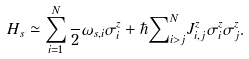<formula> <loc_0><loc_0><loc_500><loc_500>H _ { s } \simeq \sum _ { i = 1 } ^ { N } \frac { } { 2 } \omega _ { s , i } \sigma ^ { z } _ { i } + \hbar { \sum } _ { i > j } ^ { N } J ^ { z } _ { i , j } \sigma ^ { z } _ { i } \sigma ^ { z } _ { j } .</formula> 